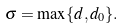Convert formula to latex. <formula><loc_0><loc_0><loc_500><loc_500>\sigma = \max \{ d , d _ { 0 } \} .</formula> 